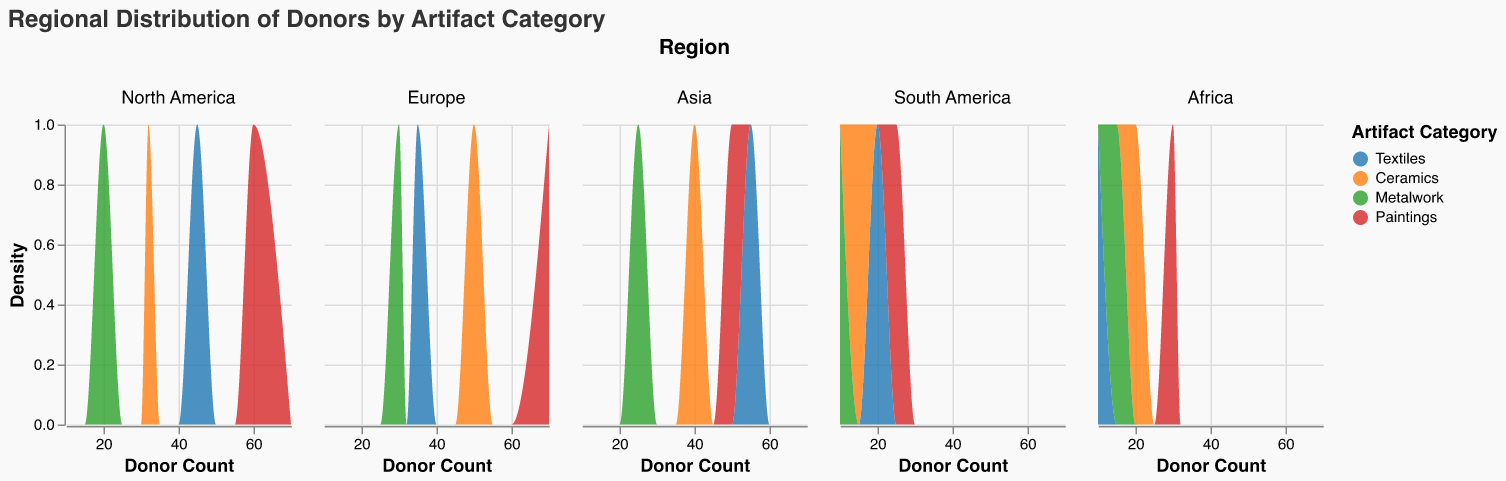What is the title of the figure? The title is typically found at the top of the figure, and it provides a description of what the figure represents. In this case, the title explicitly states the focus of the visualization.
Answer: Regional Distribution of Donors by Artifact Category Which region has the highest donor count for Paintings? By examining the density areas in the subplots for different regions, we can identify the region with the highest donor count for Paintings.
Answer: Europe What is the range of Donor Count for Textiles in North America? Look at the density plot for Textiles in the North America subplot and observe the x-axis range for this category.
Answer: 0 to 45 Which artifact category has the most donor counts in Asia? By comparing the density areas of all artifact categories in the Asia subplot, the one with the largest density area represents the highest donor count.
Answer: Textiles What is the combined donor count for Metalwork in Europe and Asia? Add the donor counts for Metalwork from both the Europe and Asia subplots. Europe has 30 and Asia has 25.
Answer: 55 Which region has the least donor count for Ceramics? By comparing the density areas of Ceramics across all regions, the subplot with the smallest density area represents the least donor count.
Answer: South America Compare the donor counts for Textiles between North America and Europe. Which region has more donors? By comparing the density areas for Textiles between the North America and Europe subplots, the region with the larger density area has more donors.
Answer: North America What is the color code used for Paintings? Look at the color legend in the figure to determine the color assigned to Paintings.
Answer: Red What is the density of donors for Metalwork in Africa at a donor count of 15? By examining the Africa subplot for the Metalwork category and locating the donor count of 15 on the x-axis, determine the corresponding y-value, which represents the density.
Answer: The exact density value needs to be read from the particular point on the plot What is the difference in donor counts for Ceramics between North America and South America? Subtract the donor count for Ceramics in South America from that in North America. North America has 32 and South America has 15.
Answer: 17 